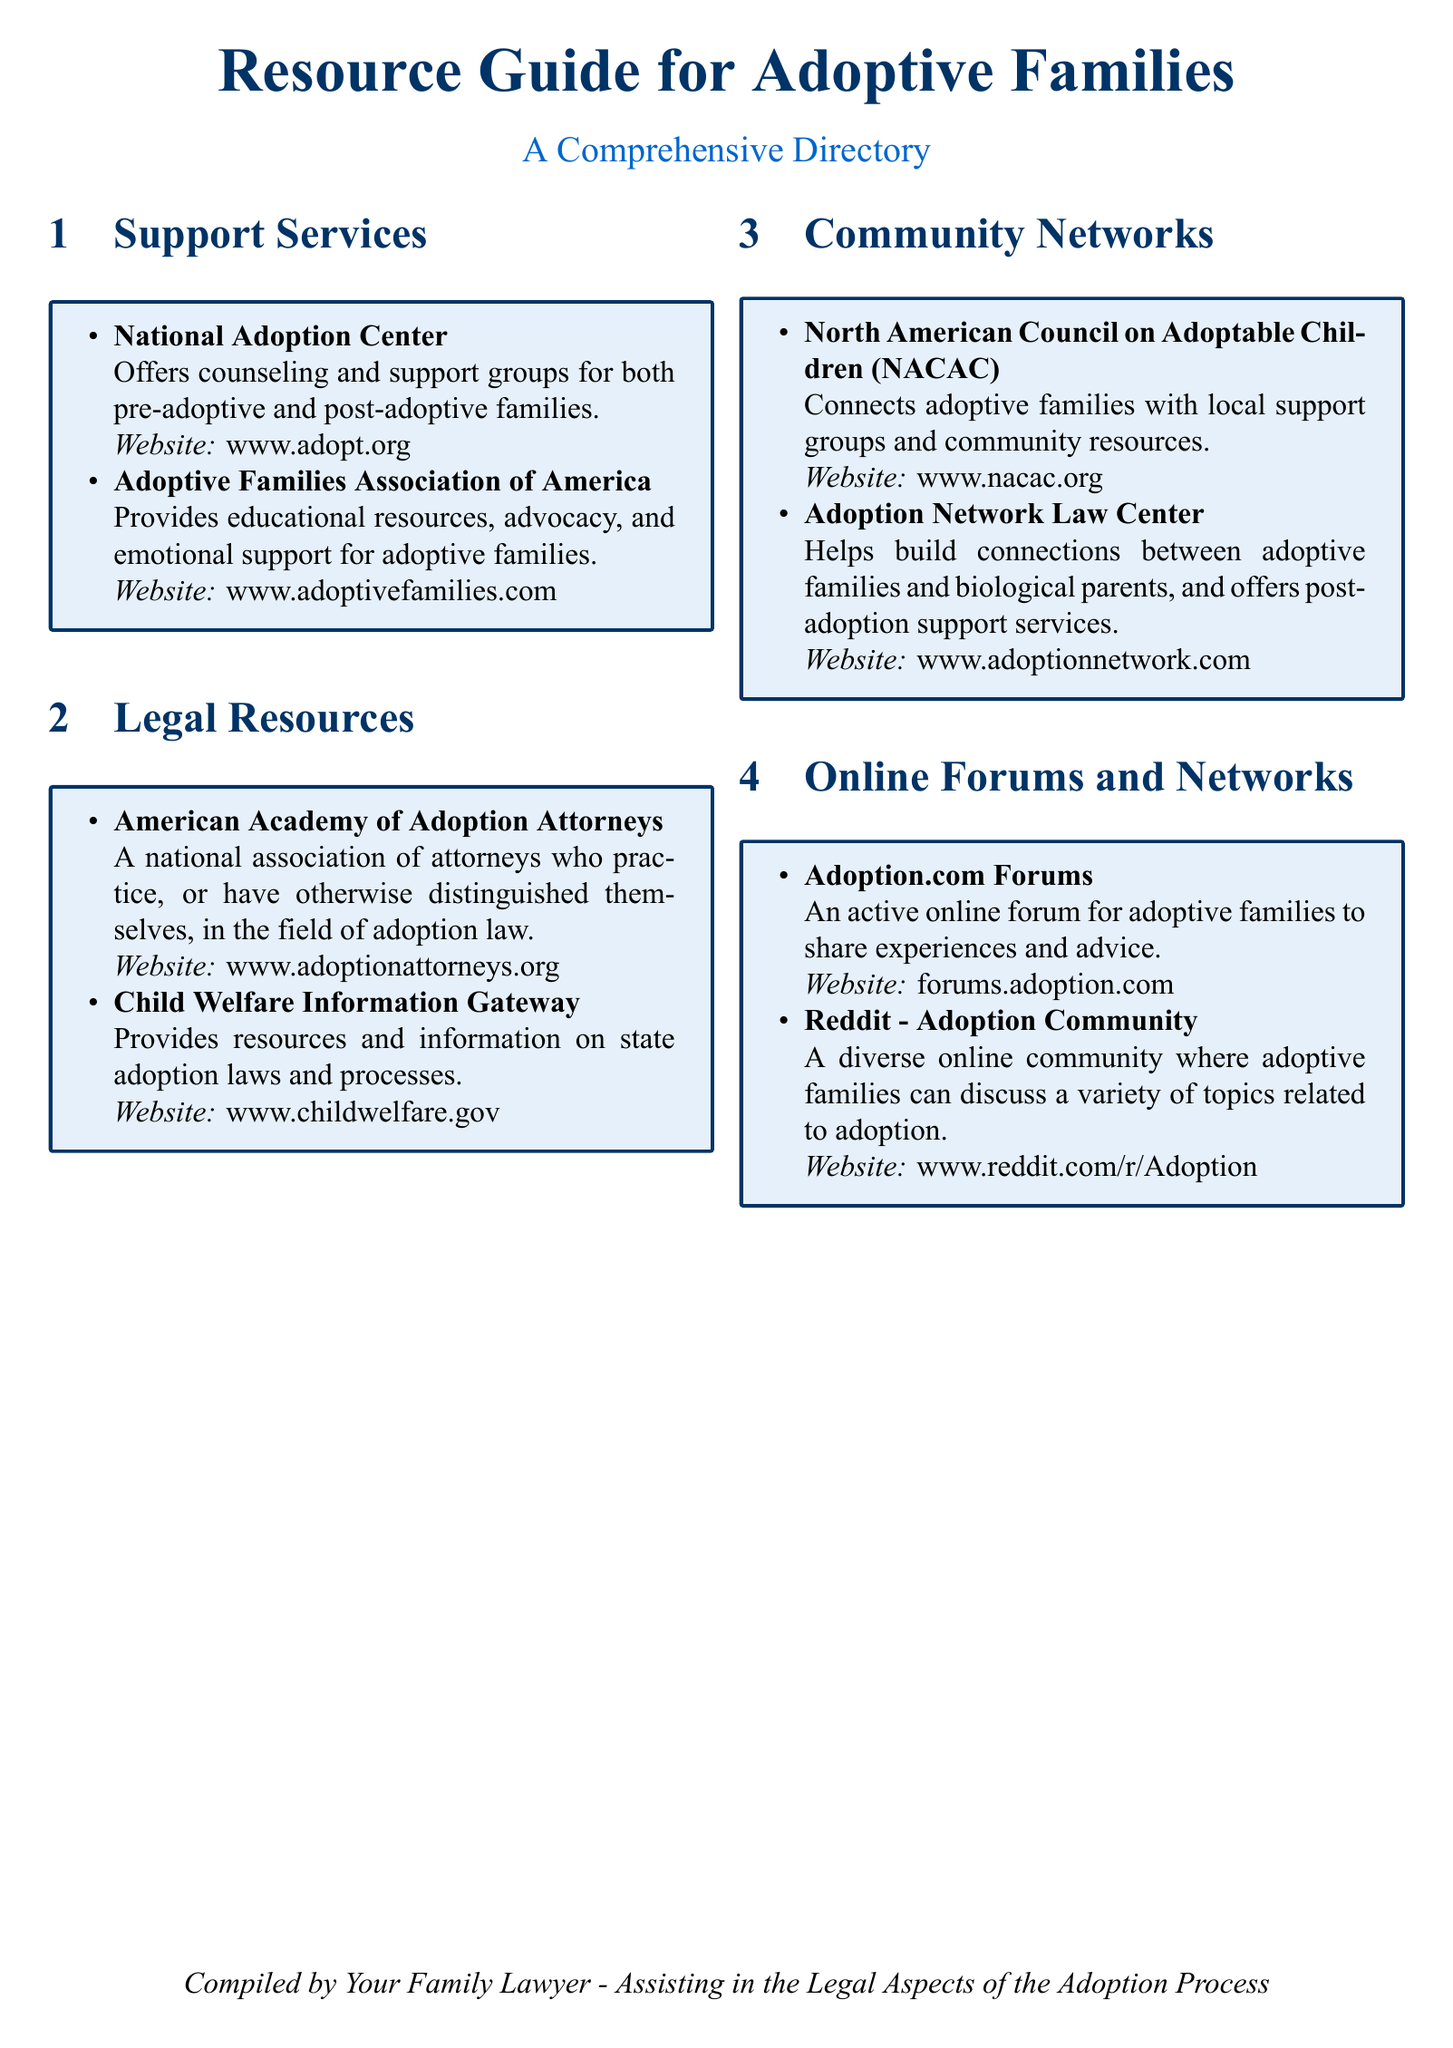What is the title of the document? The title of the document is stated at the top of the document and is clearly formatted.
Answer: Resource Guide for Adoptive Families How many sections are in the document? The document contains four distinct sections providing resources for adoptive families.
Answer: Four What organization offers emotional support for adoptive families? The document lists specific organizations under each resource category, including their services.
Answer: Adoptive Families Association of America Which resource provides information on state adoption laws? The document provides names and descriptions of organizations relevant to adoptive families and their legal concerns.
Answer: Child Welfare Information Gateway What is the website for the National Adoption Center? Each organization listed has a corresponding website provided for further information.
Answer: www.adopt.org Which community network connects adoptive families with local support? The document categorizes networks and specifies their functions relevant to adoptive families.
Answer: North American Council on Adoptable Children (NACAC) What type of online community is mentioned in the document? The document includes a section dedicated to online forums and networks specifically for adoptive families.
Answer: Online forum Who compiled the document? The document credits a specific individual or entity responsible for its compilation in the footer.
Answer: Your Family Lawyer 